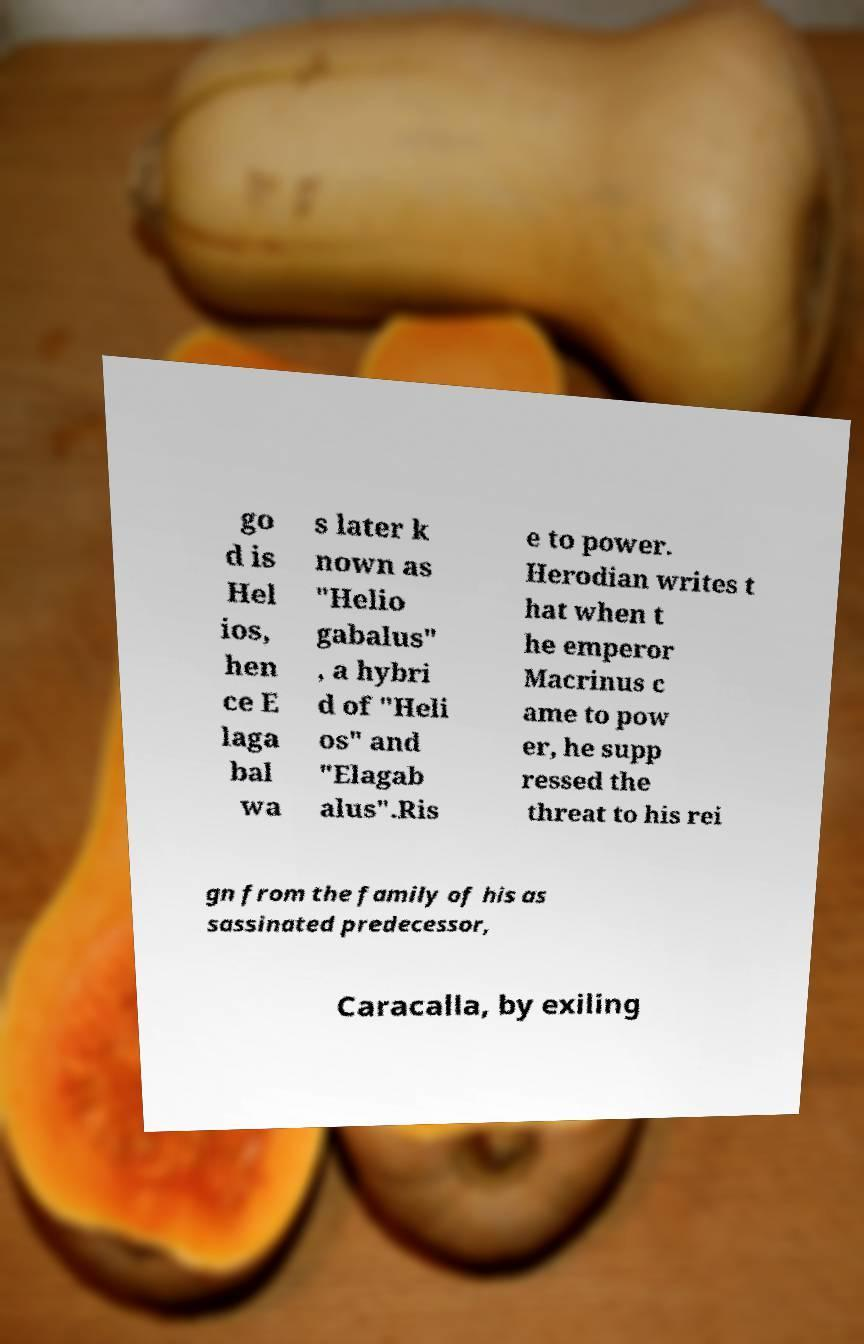Please read and relay the text visible in this image. What does it say? go d is Hel ios, hen ce E laga bal wa s later k nown as "Helio gabalus" , a hybri d of "Heli os" and "Elagab alus".Ris e to power. Herodian writes t hat when t he emperor Macrinus c ame to pow er, he supp ressed the threat to his rei gn from the family of his as sassinated predecessor, Caracalla, by exiling 